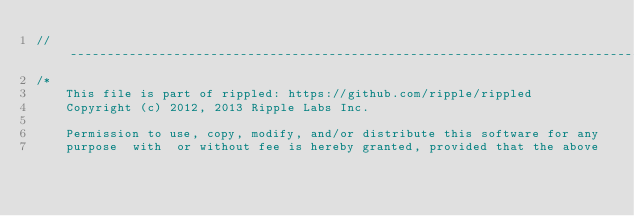Convert code to text. <code><loc_0><loc_0><loc_500><loc_500><_C++_>//------------------------------------------------------------------------------
/*
    This file is part of rippled: https://github.com/ripple/rippled
    Copyright (c) 2012, 2013 Ripple Labs Inc.

    Permission to use, copy, modify, and/or distribute this software for any
    purpose  with  or without fee is hereby granted, provided that the above</code> 